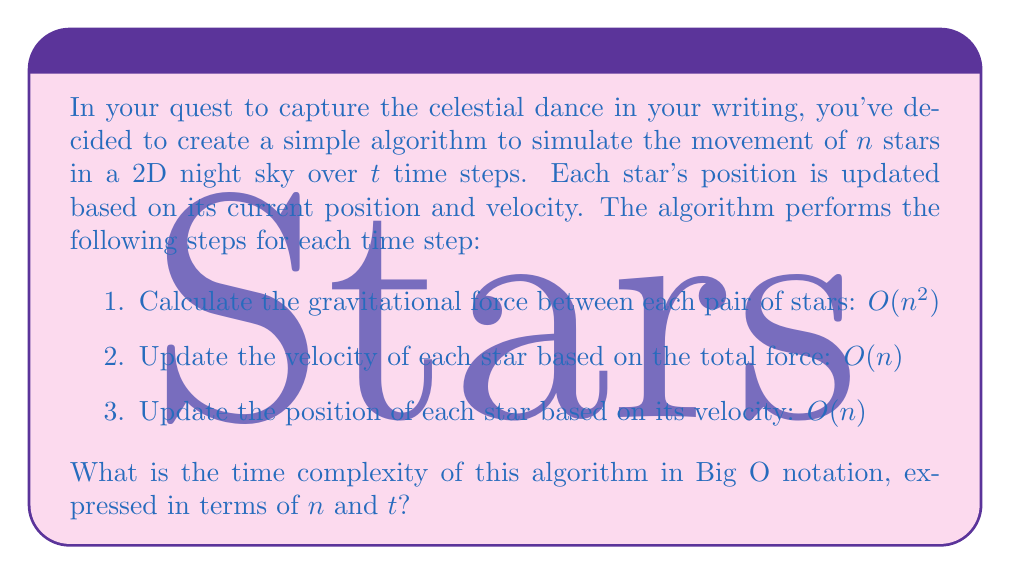What is the answer to this math problem? Let's break down the algorithm and analyze its time complexity step by step:

1. Calculating gravitational forces:
   This step involves comparing each star with every other star, resulting in $\frac{n(n-1)}{2}$ comparisons. This is a quadratic operation, so its time complexity is $O(n^2)$.

2. Updating velocities:
   We update the velocity of each star once, which is a linear operation with time complexity $O(n)$.

3. Updating positions:
   Similarly, we update the position of each star once, which is also a linear operation with time complexity $O(n)$.

For a single time step, the total time complexity is:
$O(n^2) + O(n) + O(n) = O(n^2)$

Since we perform these operations for $t$ time steps, we multiply the complexity by $t$:

$O(n^2) * t = O(n^2t)$

Therefore, the overall time complexity of the algorithm is $O(n^2t)$.

This quadratic relationship with the number of stars ($n$) means that as we increase the number of stars in our simulation, the computation time will grow rapidly. The linear relationship with time steps ($t$) indicates that doubling the simulation duration will double the computation time.
Answer: $O(n^2t)$ 